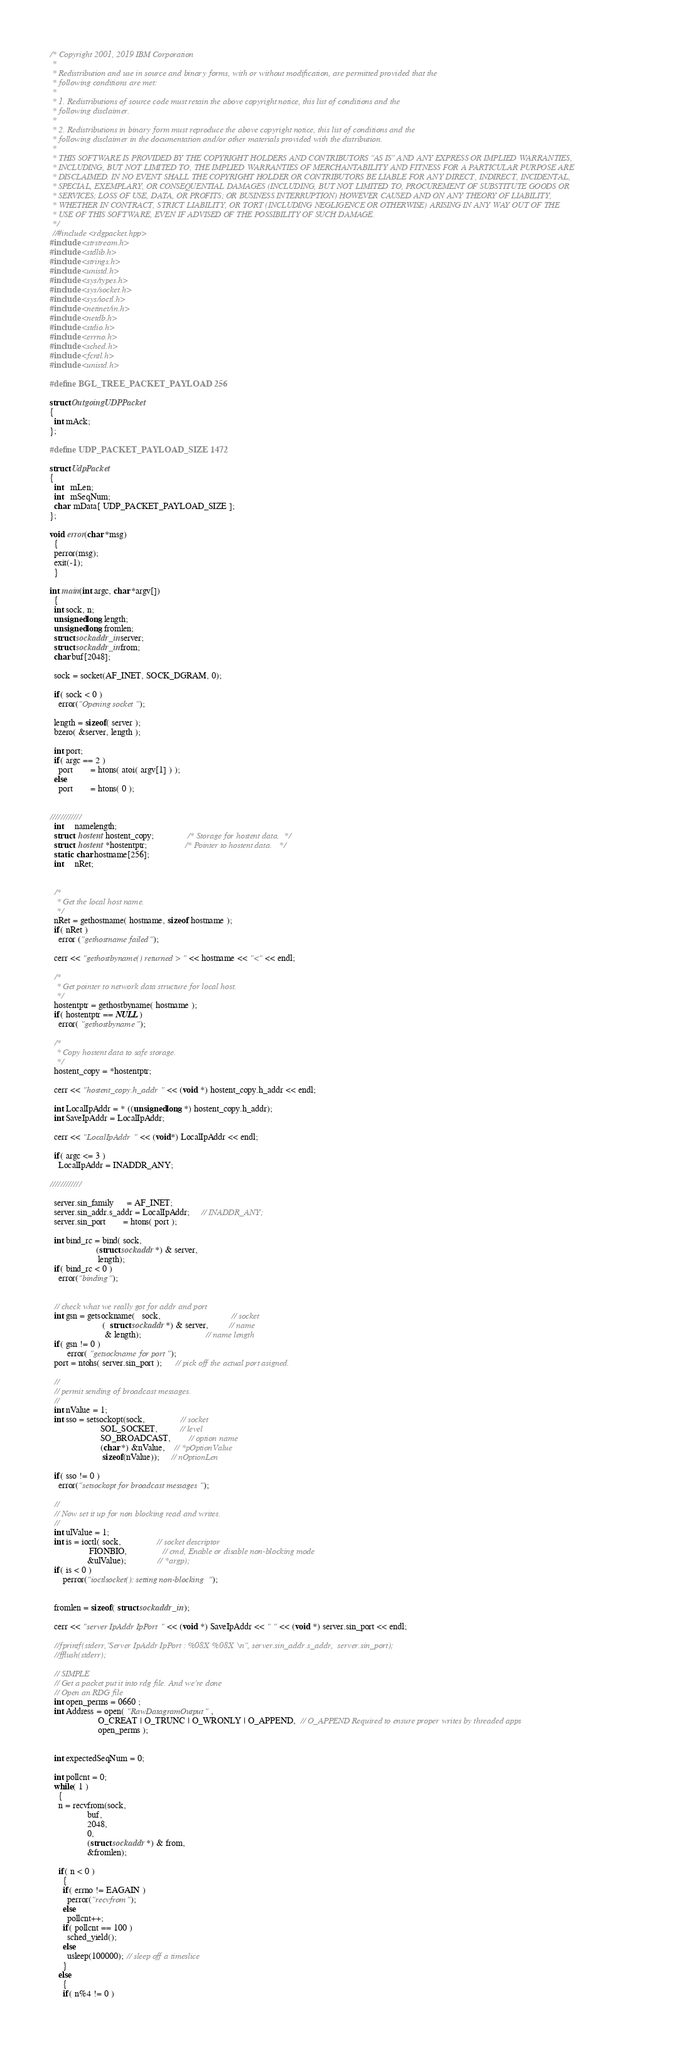Convert code to text. <code><loc_0><loc_0><loc_500><loc_500><_C++_>/* Copyright 2001, 2019 IBM Corporation
 *
 * Redistribution and use in source and binary forms, with or without modification, are permitted provided that the 
 * following conditions are met:
 *
 * 1. Redistributions of source code must retain the above copyright notice, this list of conditions and the 
 * following disclaimer.
 *
 * 2. Redistributions in binary form must reproduce the above copyright notice, this list of conditions and the 
 * following disclaimer in the documentation and/or other materials provided with the distribution.
 *
 * THIS SOFTWARE IS PROVIDED BY THE COPYRIGHT HOLDERS AND CONTRIBUTORS "AS IS" AND ANY EXPRESS OR IMPLIED WARRANTIES, 
 * INCLUDING, BUT NOT LIMITED TO, THE IMPLIED WARRANTIES OF MERCHANTABILITY AND FITNESS FOR A PARTICULAR PURPOSE ARE 
 * DISCLAIMED. IN NO EVENT SHALL THE COPYRIGHT HOLDER OR CONTRIBUTORS BE LIABLE FOR ANY DIRECT, INDIRECT, INCIDENTAL, 
 * SPECIAL, EXEMPLARY, OR CONSEQUENTIAL DAMAGES (INCLUDING, BUT NOT LIMITED TO, PROCUREMENT OF SUBSTITUTE GOODS OR 
 * SERVICES; LOSS OF USE, DATA, OR PROFITS; OR BUSINESS INTERRUPTION) HOWEVER CAUSED AND ON ANY THEORY OF LIABILITY, 
 * WHETHER IN CONTRACT, STRICT LIABILITY, OR TORT (INCLUDING NEGLIGENCE OR OTHERWISE) ARISING IN ANY WAY OUT OF THE 
 * USE OF THIS SOFTWARE, EVEN IF ADVISED OF THE POSSIBILITY OF SUCH DAMAGE.
 */
 //#include <rdgpacket.hpp>
#include <strstream.h>
#include <stdlib.h>
#include <strings.h>
#include <unistd.h>
#include <sys/types.h>
#include <sys/socket.h>
#include <sys/ioctl.h>
#include <netinet/in.h>
#include <netdb.h>
#include <stdio.h>
#include <errno.h>
#include <sched.h>
#include <fcntl.h>
#include <unistd.h>

#define BGL_TREE_PACKET_PAYLOAD 256

struct OutgoingUDPPacket
{
  int mAck;
};

#define UDP_PACKET_PAYLOAD_SIZE 1472

struct UdpPacket
{
  int   mLen;
  int   mSeqNum;
  char  mData[ UDP_PACKET_PAYLOAD_SIZE ];
};

void error(char *msg)
  {
  perror(msg);
  exit(-1);
  }

int main(int argc, char *argv[])
  {
  int sock, n;
  unsigned long length;
  unsigned long fromlen;
  struct sockaddr_in server;
  struct sockaddr_in from;
  char buf[2048];

  sock = socket(AF_INET, SOCK_DGRAM, 0);

  if( sock < 0 )
    error("Opening socket");

  length = sizeof( server );
  bzero( &server, length );

  int port;
  if( argc == 2 )
    port        = htons( atoi( argv[1] ) );
  else
    port        = htons( 0 );


////////////
  int     namelength;
  struct  hostent hostent_copy;               /* Storage for hostent data.  */
  struct  hostent *hostentptr;                 /* Pointer to hostent data.   */
  static  char hostname[256];
  int     nRet;


  /*
   * Get the local host name.
   */
  nRet = gethostname( hostname, sizeof hostname );
  if( nRet )
    error ("gethostname failed");

  cerr << "gethostbyname() returned >" << hostname << "<" << endl;

  /*
   * Get pointer to network data structure for local host.
   */
  hostentptr = gethostbyname( hostname );
  if( hostentptr == NULL)
    error( "gethostbyname");

  /*
   * Copy hostent data to safe storage.
   */
  hostent_copy = *hostentptr;

  cerr << "hostent_copy.h_addr " << (void *) hostent_copy.h_addr << endl;

  int LocalIpAddr = * ((unsigned long *) hostent_copy.h_addr);
  int SaveIpAddr = LocalIpAddr;

  cerr << "LocalIpAddr " << (void*) LocalIpAddr << endl;

  if( argc <= 3 )
    LocalIpAddr = INADDR_ANY;

////////////

  server.sin_family      = AF_INET;
  server.sin_addr.s_addr = LocalIpAddr;     // INADDR_ANY;
  server.sin_port        = htons( port );

  int bind_rc = bind( sock,
                     (struct sockaddr *) & server,
                      length);
  if( bind_rc < 0 )
    error("binding");


  // check what we really got for addr and port
  int gsn = getsockname(   sock,                                // socket
                        (  struct sockaddr *) & server,         // name
                         & length);                             // name length
  if( gsn != 0 )
        error( "getsockname for port");
  port = ntohs( server.sin_port );      // pick off the actual port asigned.

  //
  // permit sending of broadcast messages.
  //
  int nValue = 1;
  int sso = setsockopt(sock,                // socket
                       SOL_SOCKET,          // level
                       SO_BROADCAST,        // option name
                       (char *) &nValue,    // *pOptionValue
                        sizeof(nValue));     // nOptionLen

  if( sso != 0 )
    error("setsockopt for broadcast messages");

  //
  // Now set it up for non blocking read and writes.
  //
  int ulValue = 1;
  int is = ioctl( sock,                // socket descriptor
                  FIONBIO,                // cmd, Enable or disable non-blocking mode
                 &ulValue);              // *argp);
  if( is < 0 )
      perror("ioctlsocket(): setting non-blocking");


  fromlen = sizeof( struct sockaddr_in );

  cerr << "server IpAddr IpPort " << (void *) SaveIpAddr << " " << (void *) server.sin_port << endl;

  //fprintf(stderr,"Server IpAddr IpPort : %08X %08X \n", server.sin_addr.s_addr,  server.sin_port);
  //fflush(stderr);

  // SIMPLE 
  // Get a packet put it into rdg file. And we're done
  // Open an RDG file
  int open_perms = 0660 ;
  int Address = open( "RawDatagramOutput" ,
                      O_CREAT | O_TRUNC | O_WRONLY | O_APPEND,  // O_APPEND Required to ensure proper writes by threaded apps
                      open_perms );
  

  int expectedSeqNum = 0;

  int pollcnt = 0;
  while( 1 )
    {
    n = recvfrom(sock,
                 buf,
                 2048,
                 0,
                 (struct sockaddr *) & from,
                 &fromlen);

    if( n < 0 )
      {
      if( errno != EAGAIN )
        perror("recvfrom");
      else
        pollcnt++;
      if( pollcnt == 100 )
        sched_yield();
      else
        usleep(100000); // sleep off a timeslice
      }
    else
      {
      if( n%4 != 0 )</code> 